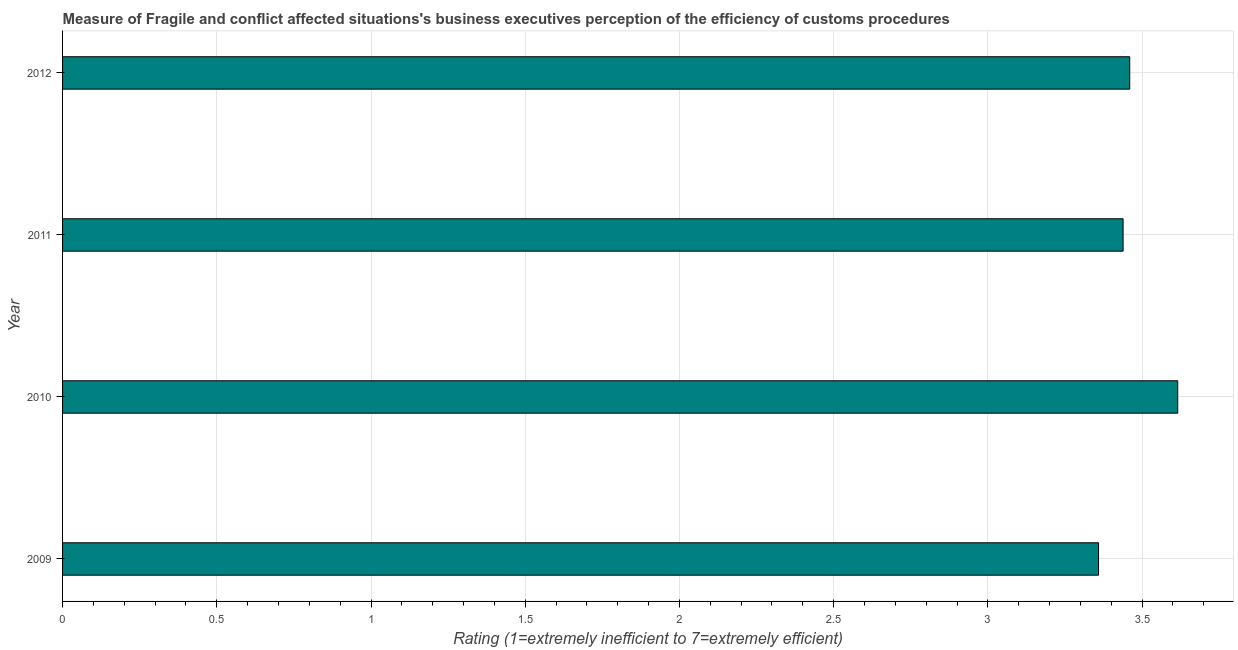Does the graph contain any zero values?
Your response must be concise. No. What is the title of the graph?
Your answer should be compact. Measure of Fragile and conflict affected situations's business executives perception of the efficiency of customs procedures. What is the label or title of the X-axis?
Give a very brief answer. Rating (1=extremely inefficient to 7=extremely efficient). What is the rating measuring burden of customs procedure in 2011?
Provide a succinct answer. 3.44. Across all years, what is the maximum rating measuring burden of customs procedure?
Offer a terse response. 3.62. Across all years, what is the minimum rating measuring burden of customs procedure?
Make the answer very short. 3.36. In which year was the rating measuring burden of customs procedure maximum?
Give a very brief answer. 2010. In which year was the rating measuring burden of customs procedure minimum?
Keep it short and to the point. 2009. What is the sum of the rating measuring burden of customs procedure?
Provide a short and direct response. 13.87. What is the difference between the rating measuring burden of customs procedure in 2011 and 2012?
Provide a short and direct response. -0.02. What is the average rating measuring burden of customs procedure per year?
Your response must be concise. 3.47. What is the median rating measuring burden of customs procedure?
Give a very brief answer. 3.45. What is the ratio of the rating measuring burden of customs procedure in 2010 to that in 2012?
Your answer should be very brief. 1.04. Is the rating measuring burden of customs procedure in 2009 less than that in 2011?
Your response must be concise. Yes. What is the difference between the highest and the second highest rating measuring burden of customs procedure?
Make the answer very short. 0.16. Is the sum of the rating measuring burden of customs procedure in 2009 and 2012 greater than the maximum rating measuring burden of customs procedure across all years?
Your answer should be very brief. Yes. What is the difference between the highest and the lowest rating measuring burden of customs procedure?
Make the answer very short. 0.26. In how many years, is the rating measuring burden of customs procedure greater than the average rating measuring burden of customs procedure taken over all years?
Make the answer very short. 1. Are the values on the major ticks of X-axis written in scientific E-notation?
Make the answer very short. No. What is the Rating (1=extremely inefficient to 7=extremely efficient) in 2009?
Offer a very short reply. 3.36. What is the Rating (1=extremely inefficient to 7=extremely efficient) in 2010?
Ensure brevity in your answer.  3.62. What is the Rating (1=extremely inefficient to 7=extremely efficient) in 2011?
Your response must be concise. 3.44. What is the Rating (1=extremely inefficient to 7=extremely efficient) in 2012?
Ensure brevity in your answer.  3.46. What is the difference between the Rating (1=extremely inefficient to 7=extremely efficient) in 2009 and 2010?
Your answer should be compact. -0.26. What is the difference between the Rating (1=extremely inefficient to 7=extremely efficient) in 2009 and 2011?
Provide a short and direct response. -0.08. What is the difference between the Rating (1=extremely inefficient to 7=extremely efficient) in 2009 and 2012?
Provide a short and direct response. -0.1. What is the difference between the Rating (1=extremely inefficient to 7=extremely efficient) in 2010 and 2011?
Keep it short and to the point. 0.18. What is the difference between the Rating (1=extremely inefficient to 7=extremely efficient) in 2010 and 2012?
Offer a very short reply. 0.16. What is the difference between the Rating (1=extremely inefficient to 7=extremely efficient) in 2011 and 2012?
Your answer should be compact. -0.02. What is the ratio of the Rating (1=extremely inefficient to 7=extremely efficient) in 2009 to that in 2010?
Your answer should be compact. 0.93. What is the ratio of the Rating (1=extremely inefficient to 7=extremely efficient) in 2010 to that in 2011?
Ensure brevity in your answer.  1.05. What is the ratio of the Rating (1=extremely inefficient to 7=extremely efficient) in 2010 to that in 2012?
Give a very brief answer. 1.04. What is the ratio of the Rating (1=extremely inefficient to 7=extremely efficient) in 2011 to that in 2012?
Your answer should be compact. 0.99. 